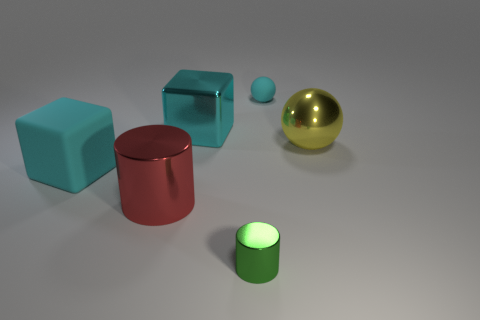Add 3 tiny cyan metallic cylinders. How many objects exist? 9 Add 2 small cyan rubber cylinders. How many small cyan rubber cylinders exist? 2 Subtract 1 green cylinders. How many objects are left? 5 Subtract all red objects. Subtract all big cylinders. How many objects are left? 4 Add 2 big cyan blocks. How many big cyan blocks are left? 4 